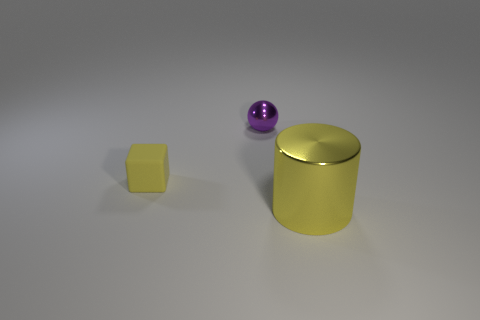Are there any shiny cylinders behind the tiny thing that is in front of the tiny purple shiny object that is on the right side of the small matte cube?
Your response must be concise. No. There is a small object in front of the small sphere; is it the same color as the large cylinder?
Ensure brevity in your answer.  Yes. What number of balls are small brown rubber objects or tiny purple things?
Offer a very short reply. 1. What shape is the yellow object that is to the left of the small object that is behind the tiny rubber object?
Provide a succinct answer. Cube. What size is the metal object to the right of the metal object to the left of the yellow object to the right of the yellow rubber object?
Provide a short and direct response. Large. Does the purple metal ball have the same size as the yellow matte thing?
Give a very brief answer. Yes. What number of things are either metallic cylinders or green rubber cylinders?
Make the answer very short. 1. There is a shiny thing in front of the tiny thing right of the block; how big is it?
Offer a very short reply. Large. The yellow cylinder has what size?
Make the answer very short. Large. There is a object that is behind the metallic cylinder and on the right side of the rubber cube; what is its shape?
Keep it short and to the point. Sphere. 